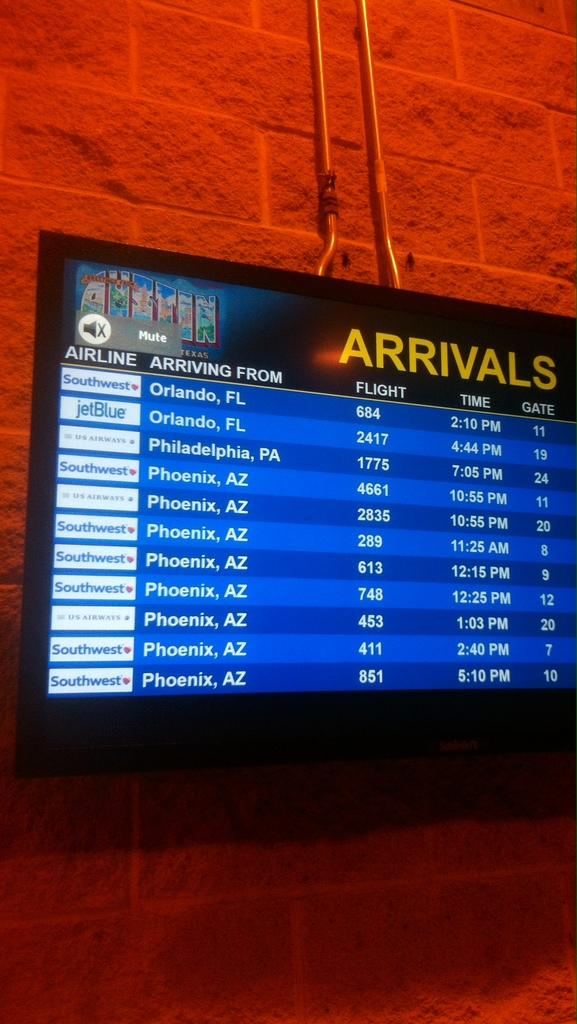<image>
Describe the image concisely. The flight schedule is displayed on the wall for arrival names, times and gates. 